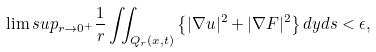Convert formula to latex. <formula><loc_0><loc_0><loc_500><loc_500>\lim s u p _ { r \rightarrow 0 ^ { + } } \frac { 1 } { r } \iint _ { Q _ { r } ( x , t ) } \left \{ | \nabla u | ^ { 2 } + | \nabla F | ^ { 2 } \right \} d y d s < \epsilon ,</formula> 